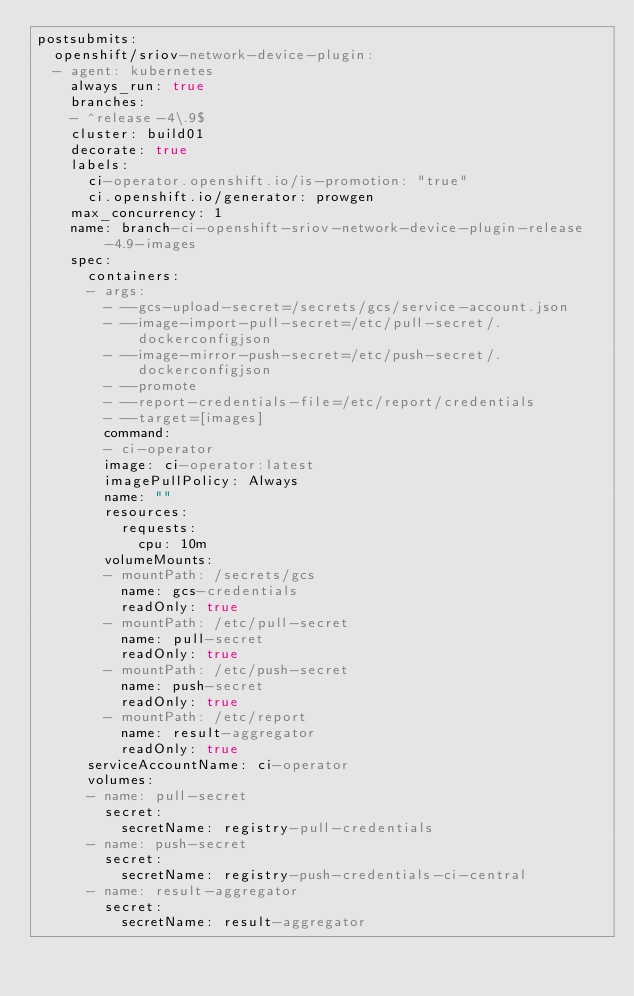Convert code to text. <code><loc_0><loc_0><loc_500><loc_500><_YAML_>postsubmits:
  openshift/sriov-network-device-plugin:
  - agent: kubernetes
    always_run: true
    branches:
    - ^release-4\.9$
    cluster: build01
    decorate: true
    labels:
      ci-operator.openshift.io/is-promotion: "true"
      ci.openshift.io/generator: prowgen
    max_concurrency: 1
    name: branch-ci-openshift-sriov-network-device-plugin-release-4.9-images
    spec:
      containers:
      - args:
        - --gcs-upload-secret=/secrets/gcs/service-account.json
        - --image-import-pull-secret=/etc/pull-secret/.dockerconfigjson
        - --image-mirror-push-secret=/etc/push-secret/.dockerconfigjson
        - --promote
        - --report-credentials-file=/etc/report/credentials
        - --target=[images]
        command:
        - ci-operator
        image: ci-operator:latest
        imagePullPolicy: Always
        name: ""
        resources:
          requests:
            cpu: 10m
        volumeMounts:
        - mountPath: /secrets/gcs
          name: gcs-credentials
          readOnly: true
        - mountPath: /etc/pull-secret
          name: pull-secret
          readOnly: true
        - mountPath: /etc/push-secret
          name: push-secret
          readOnly: true
        - mountPath: /etc/report
          name: result-aggregator
          readOnly: true
      serviceAccountName: ci-operator
      volumes:
      - name: pull-secret
        secret:
          secretName: registry-pull-credentials
      - name: push-secret
        secret:
          secretName: registry-push-credentials-ci-central
      - name: result-aggregator
        secret:
          secretName: result-aggregator
</code> 